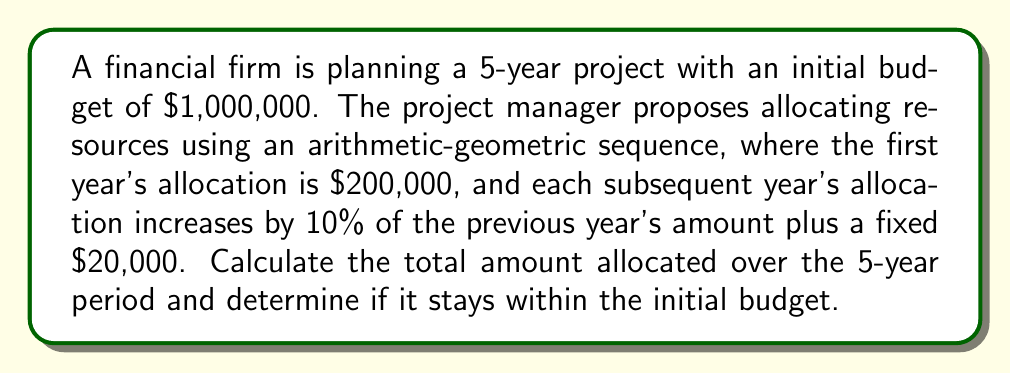Give your solution to this math problem. Let's approach this step-by-step:

1) We're dealing with an arithmetic-geometric sequence. Let's define:
   $a_n$ = allocation for year n
   $a_1 = 200,000$ (first year's allocation)

2) The sequence follows the pattern:
   $a_{n+1} = 1.1a_n + 20,000$

3) Let's calculate each year's allocation:

   Year 1: $a_1 = 200,000$
   Year 2: $a_2 = 1.1(200,000) + 20,000 = 240,000$
   Year 3: $a_3 = 1.1(240,000) + 20,000 = 284,000$
   Year 4: $a_4 = 1.1(284,000) + 20,000 = 332,400$
   Year 5: $a_5 = 1.1(332,400) + 20,000 = 385,640$

4) To find the total allocation, we sum these values:

   $S = a_1 + a_2 + a_3 + a_4 + a_5$
   $S = 200,000 + 240,000 + 284,000 + 332,400 + 385,640$
   $S = 1,442,040$

5) Compare with the initial budget:
   $1,442,040 > 1,000,000$

Therefore, the total allocation exceeds the initial budget by $442,040.
Answer: $1,442,040; Exceeds budget 